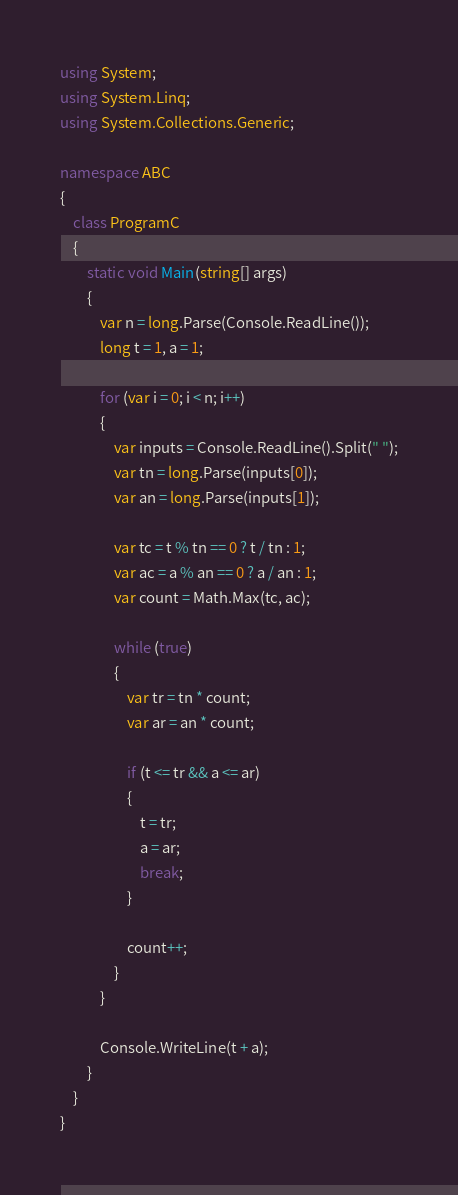Convert code to text. <code><loc_0><loc_0><loc_500><loc_500><_C#_>using System;
using System.Linq;
using System.Collections.Generic;

namespace ABC
{
    class ProgramC
    {
        static void Main(string[] args)
        {
            var n = long.Parse(Console.ReadLine());
            long t = 1, a = 1;

            for (var i = 0; i < n; i++)
            {
                var inputs = Console.ReadLine().Split(" ");
                var tn = long.Parse(inputs[0]);
                var an = long.Parse(inputs[1]);

                var tc = t % tn == 0 ? t / tn : 1;
                var ac = a % an == 0 ? a / an : 1;
                var count = Math.Max(tc, ac);

                while (true)
                {
                    var tr = tn * count;
                    var ar = an * count;

                    if (t <= tr && a <= ar)
                    {
                        t = tr;
                        a = ar;
                        break;
                    }

                    count++;
                }
            }

            Console.WriteLine(t + a);
        }
    }
}
</code> 